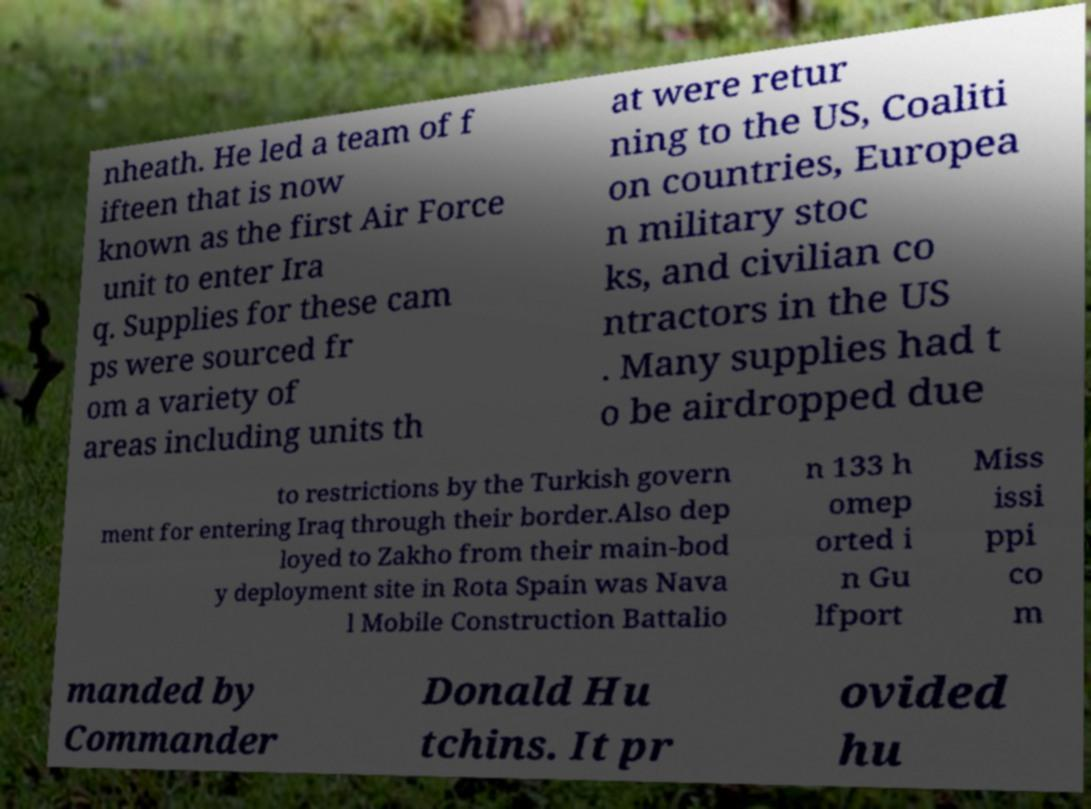Please identify and transcribe the text found in this image. nheath. He led a team of f ifteen that is now known as the first Air Force unit to enter Ira q. Supplies for these cam ps were sourced fr om a variety of areas including units th at were retur ning to the US, Coaliti on countries, Europea n military stoc ks, and civilian co ntractors in the US . Many supplies had t o be airdropped due to restrictions by the Turkish govern ment for entering Iraq through their border.Also dep loyed to Zakho from their main-bod y deployment site in Rota Spain was Nava l Mobile Construction Battalio n 133 h omep orted i n Gu lfport Miss issi ppi co m manded by Commander Donald Hu tchins. It pr ovided hu 